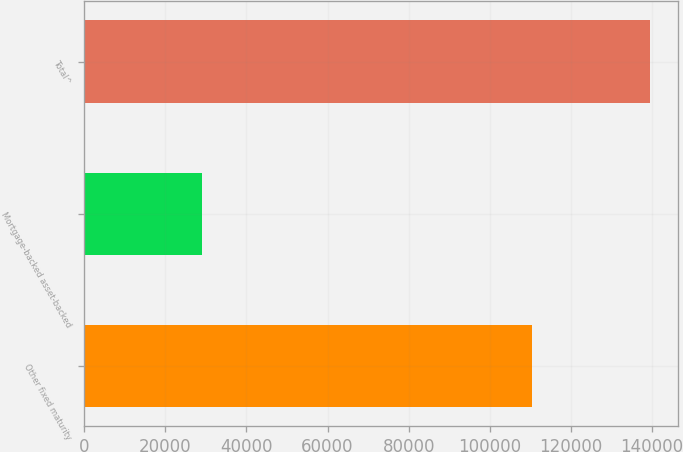<chart> <loc_0><loc_0><loc_500><loc_500><bar_chart><fcel>Other fixed maturity<fcel>Mortgage-backed asset-backed<fcel>Total^<nl><fcel>110425<fcel>29133<fcel>139558<nl></chart> 